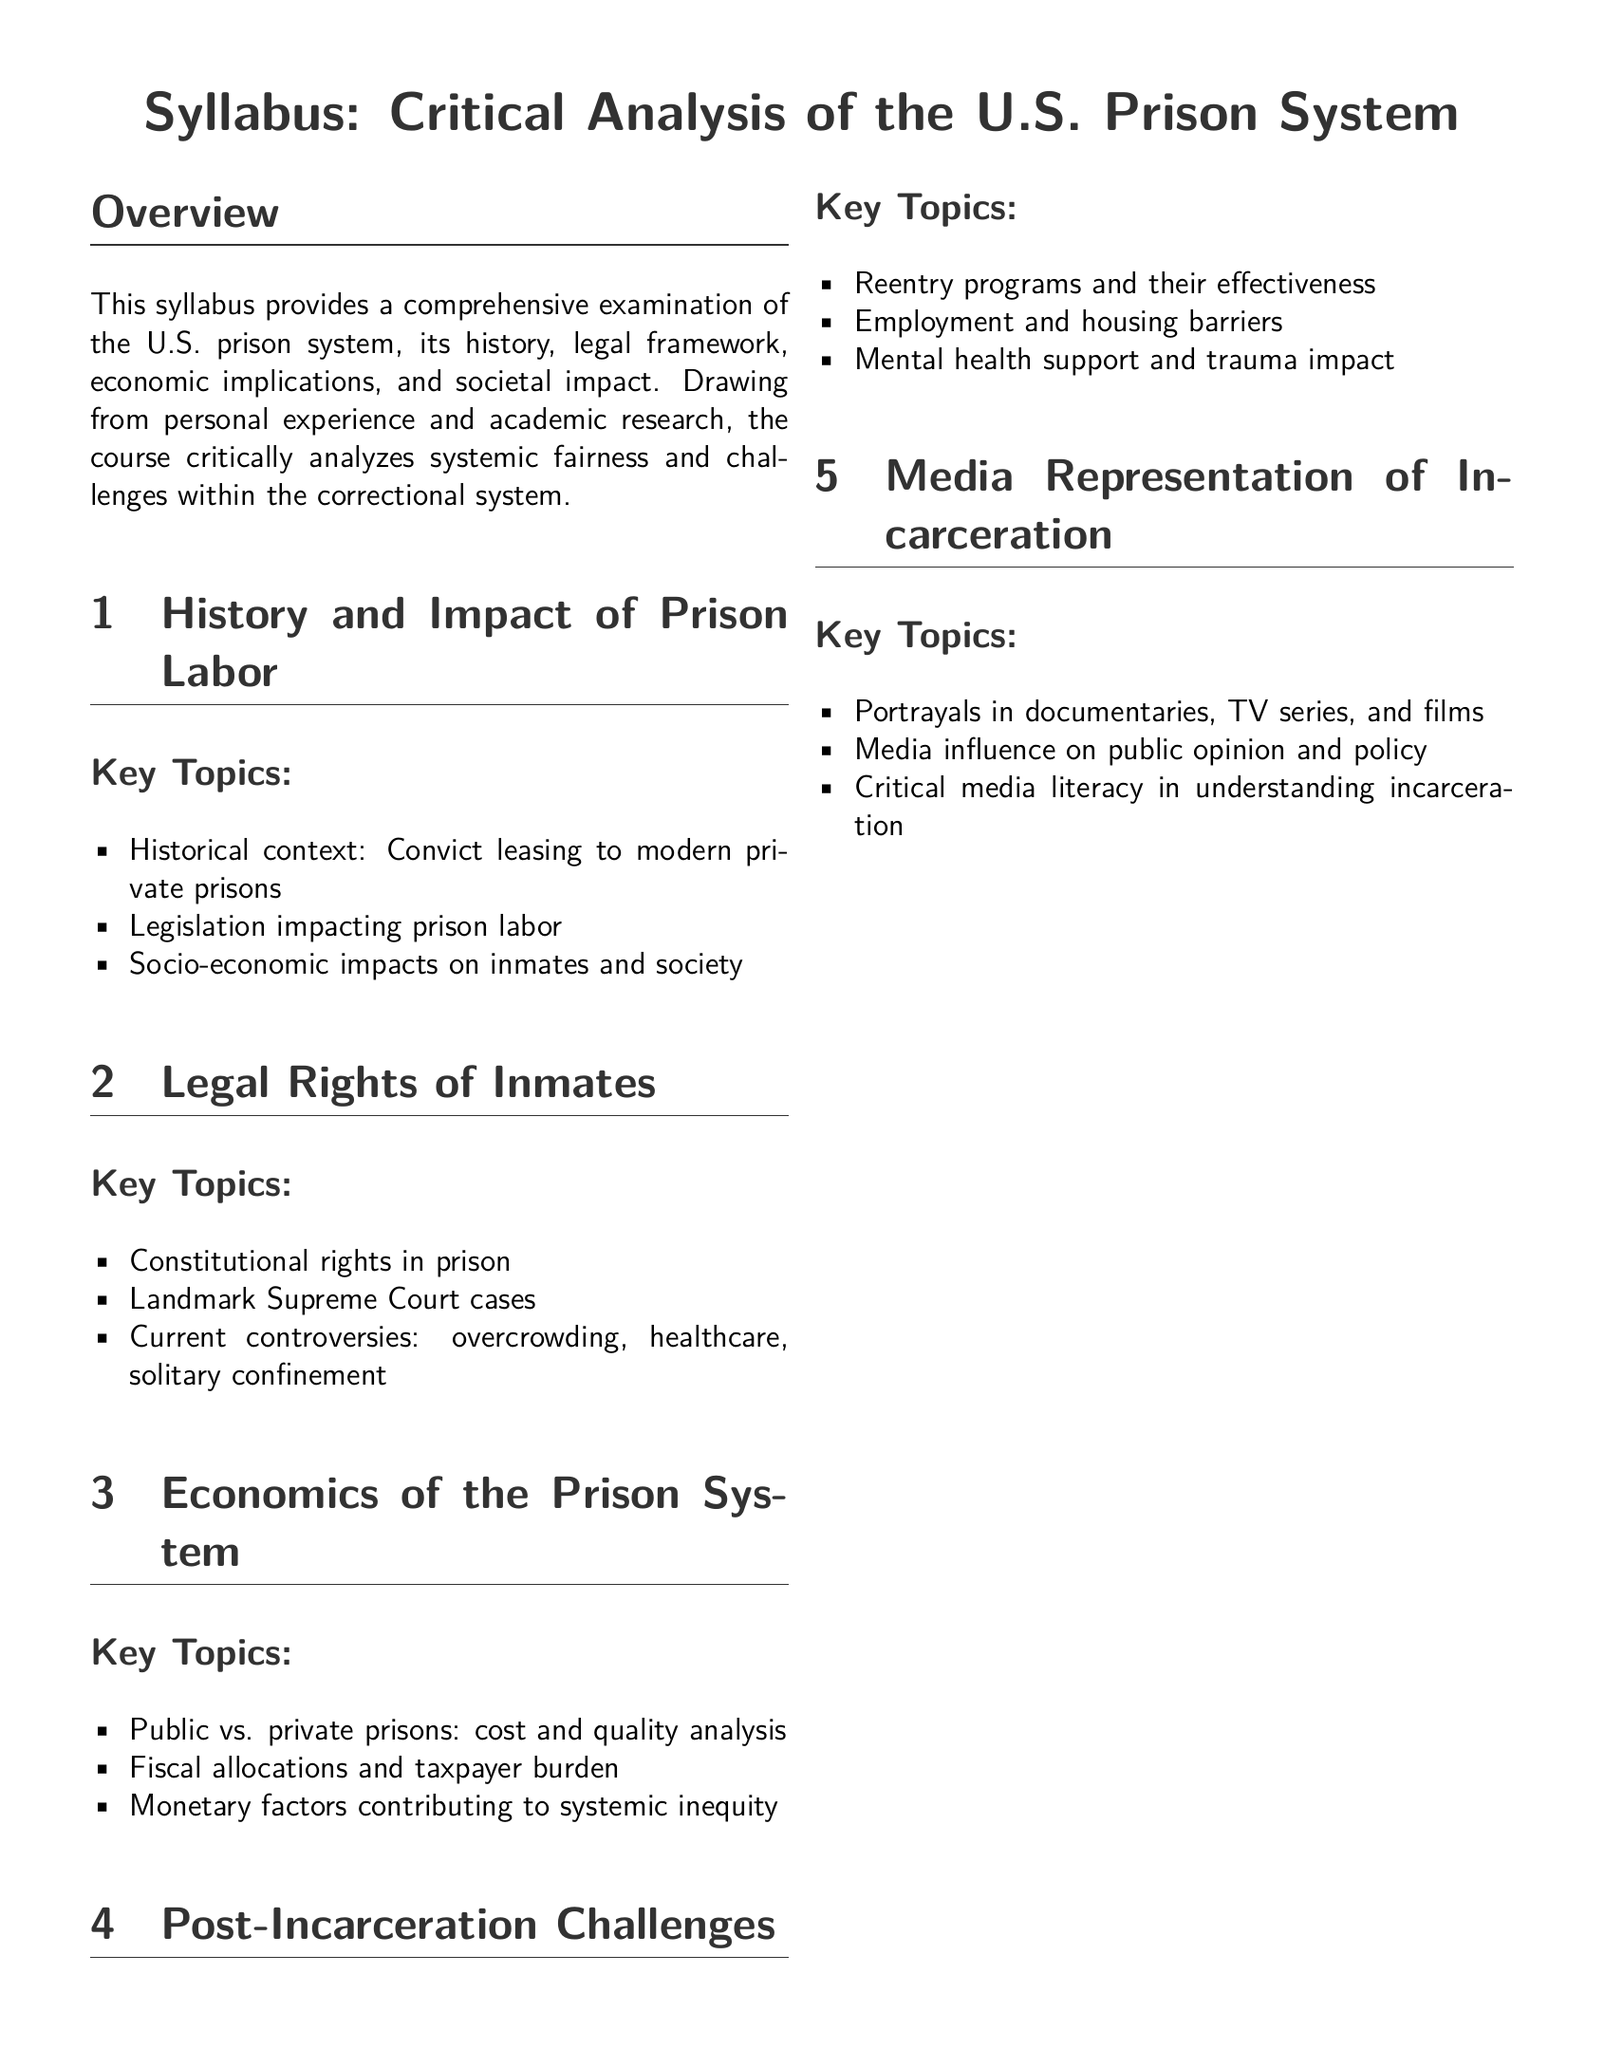What is the title of the syllabus? The title of the syllabus is presented at the beginning of the document.
Answer: Critical Analysis of the U.S. Prison System How many sections are there in the syllabus? The total number of sections is listed in the overview of the syllabus content.
Answer: Five What is one of the required readings listed? The document specifies several required readings that students must engage with.
Answer: The New Jim Crow: Mass Incarceration in the Age of Colorblindness What percentage of the assessment is based on critical analysis papers? The assessment breakdown details the weight of various components in student evaluation.
Answer: 40% Who is the intended audience for this syllabus? The target audience is specified by the instructor's note regarding the unique perspective brought to the course.
Answer: Students What does the course aim to challenge? The overarching purpose of the course is referenced in the note by the instructor.
Answer: Preconceptions Name one topic covered in the section on post-incarceration challenges. The subsection list covers various key topics related to reentry and post-incarceration issues.
Answer: Employment and housing barriers What is the main focus of the "Economics of the Prison System" section? The key topics in this section highlight specific financial aspects of the prison system.
Answer: Cost and quality analysis Which landmark Supreme Court cases could be discussed in relation to inmate rights? The syllabus indicates discussions surrounding various critical legal cases in the relevant section.
Answer: Landmark Supreme Court cases 